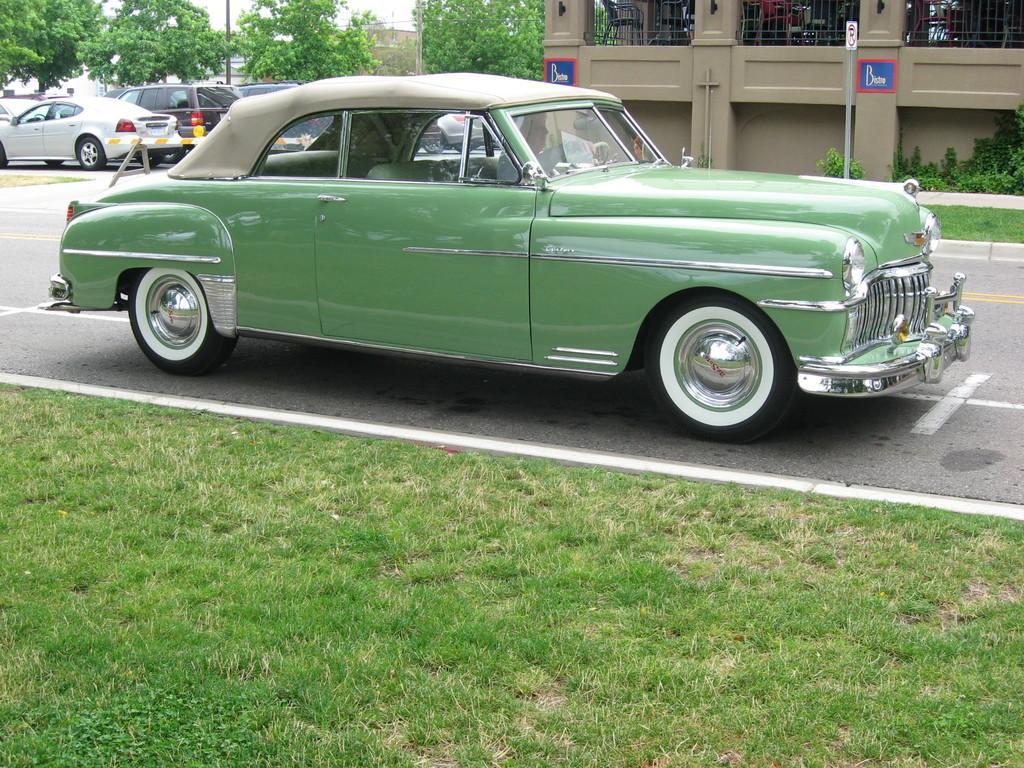Please provide a concise description of this image. In the picture there are few cars parked beside the road and there are few trees around the cars, behind the first car there is a building. 